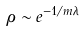<formula> <loc_0><loc_0><loc_500><loc_500>\rho \sim e ^ { - 1 / m \lambda }</formula> 